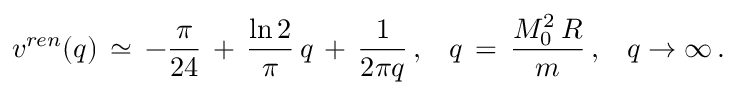<formula> <loc_0><loc_0><loc_500><loc_500>v ^ { r e n } ( q ) \, \simeq \, - \frac { \pi } { 2 4 } \, + \, \frac { \ln 2 } { \pi } \, q \, + \, \frac { 1 } { 2 \pi q } \, { , } \quad q \, = \, \frac { M _ { 0 } ^ { 2 } \, R } { m } \, { , } \quad q \to \infty \, { . }</formula> 